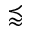<formula> <loc_0><loc_0><loc_500><loc_500>\prec a p p r o x</formula> 